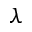<formula> <loc_0><loc_0><loc_500><loc_500>\lambda</formula> 